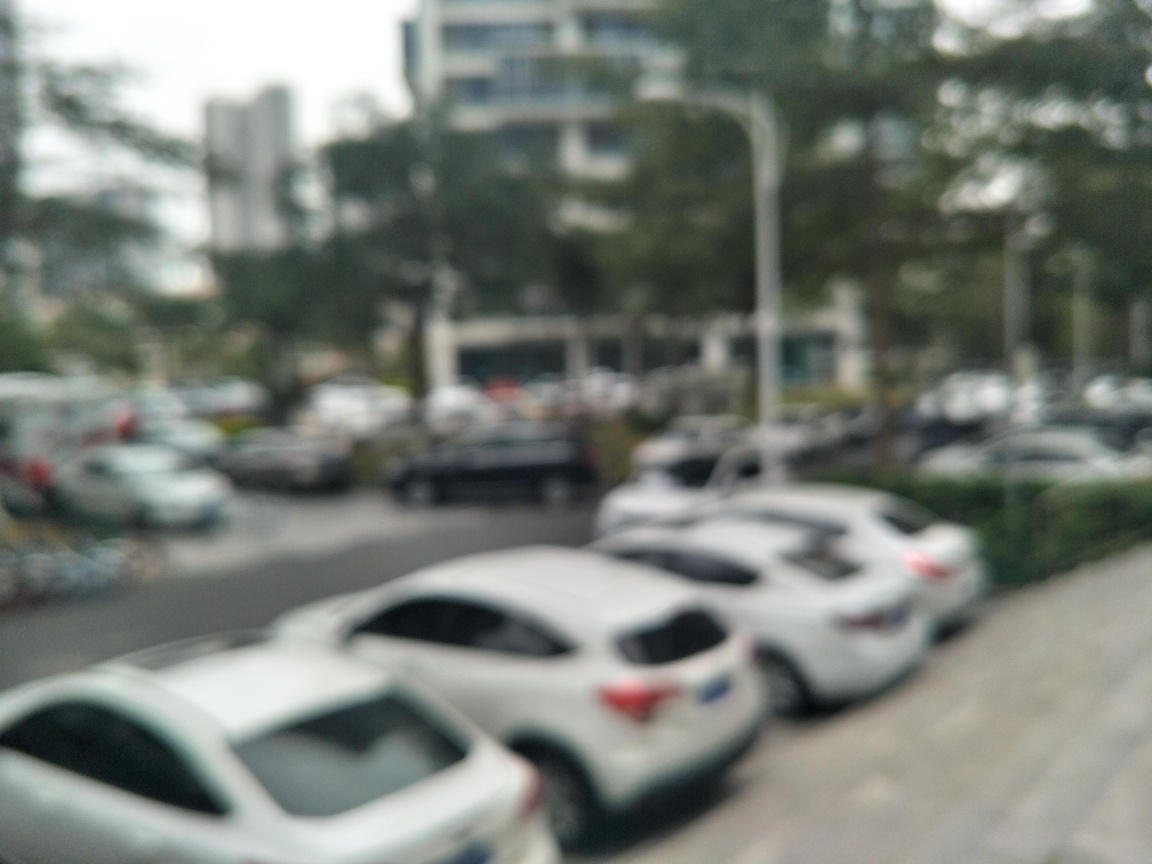What is the overall clarity of this image? The overall clarity of this image is quite low. The photo appears to be out of focus, resulting in a blur that obscures details such as the specific models of the cars and the features of the environment. Better focus or a higher resolution would greatly enhance the clarity of this image. 